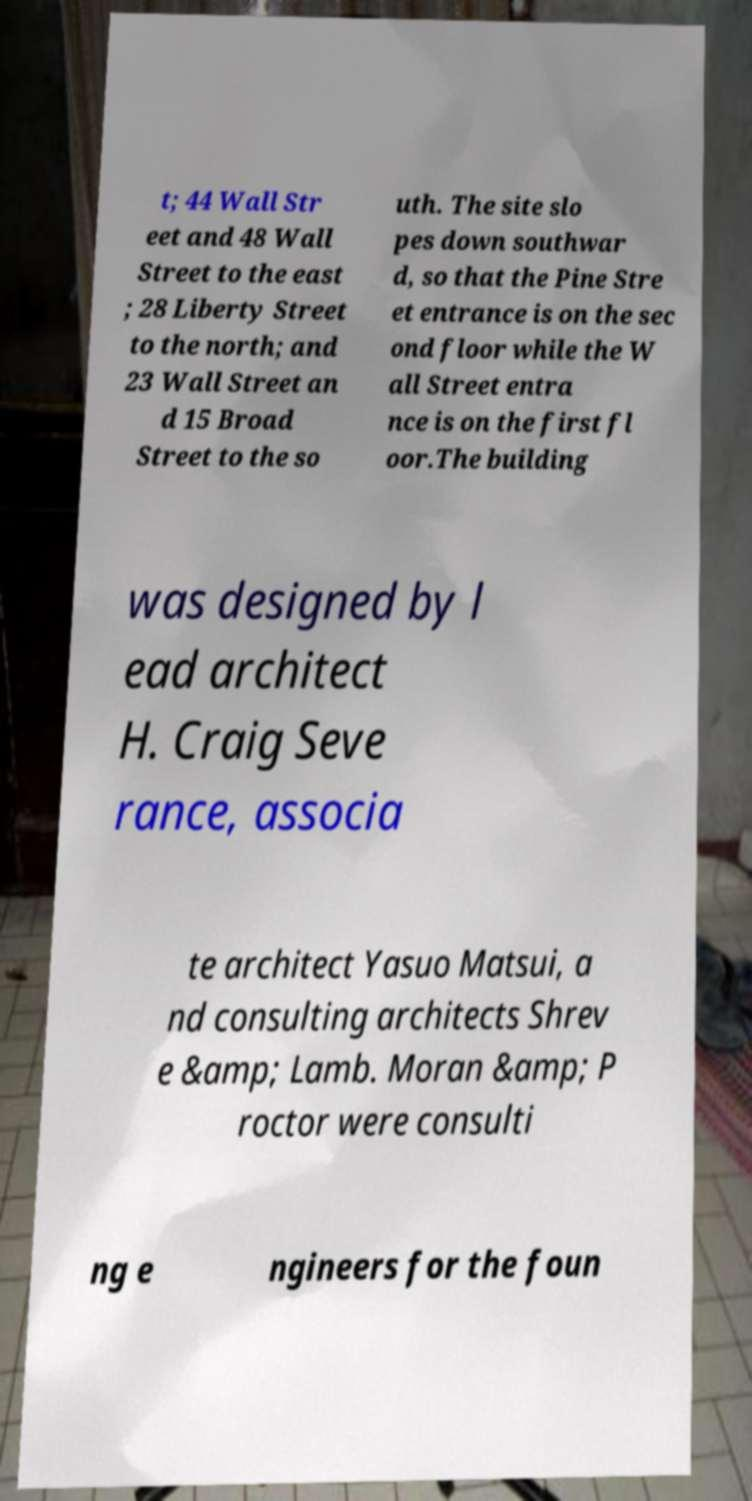Please read and relay the text visible in this image. What does it say? t; 44 Wall Str eet and 48 Wall Street to the east ; 28 Liberty Street to the north; and 23 Wall Street an d 15 Broad Street to the so uth. The site slo pes down southwar d, so that the Pine Stre et entrance is on the sec ond floor while the W all Street entra nce is on the first fl oor.The building was designed by l ead architect H. Craig Seve rance, associa te architect Yasuo Matsui, a nd consulting architects Shrev e &amp; Lamb. Moran &amp; P roctor were consulti ng e ngineers for the foun 